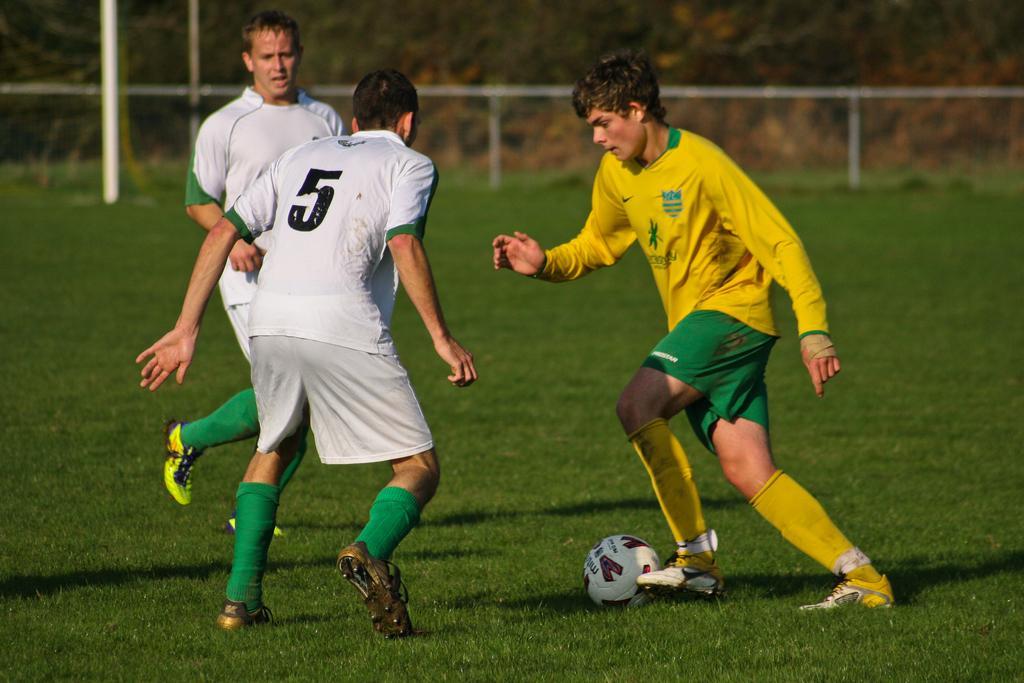How would you summarize this image in a sentence or two? In this image i can see a man in the yellow jersey hitting the football and two persons in white jersey standing. In the background i can see metal poles, grass and few trees. 